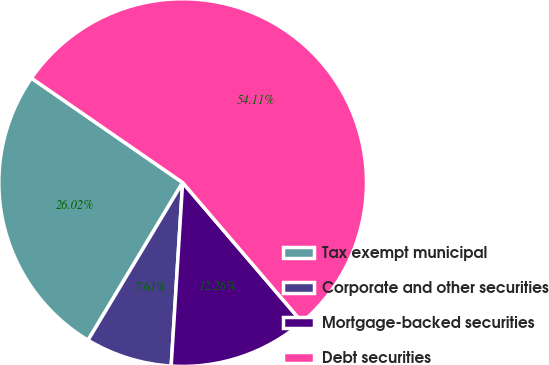Convert chart to OTSL. <chart><loc_0><loc_0><loc_500><loc_500><pie_chart><fcel>Tax exempt municipal<fcel>Corporate and other securities<fcel>Mortgage-backed securities<fcel>Debt securities<nl><fcel>26.02%<fcel>7.61%<fcel>12.26%<fcel>54.12%<nl></chart> 